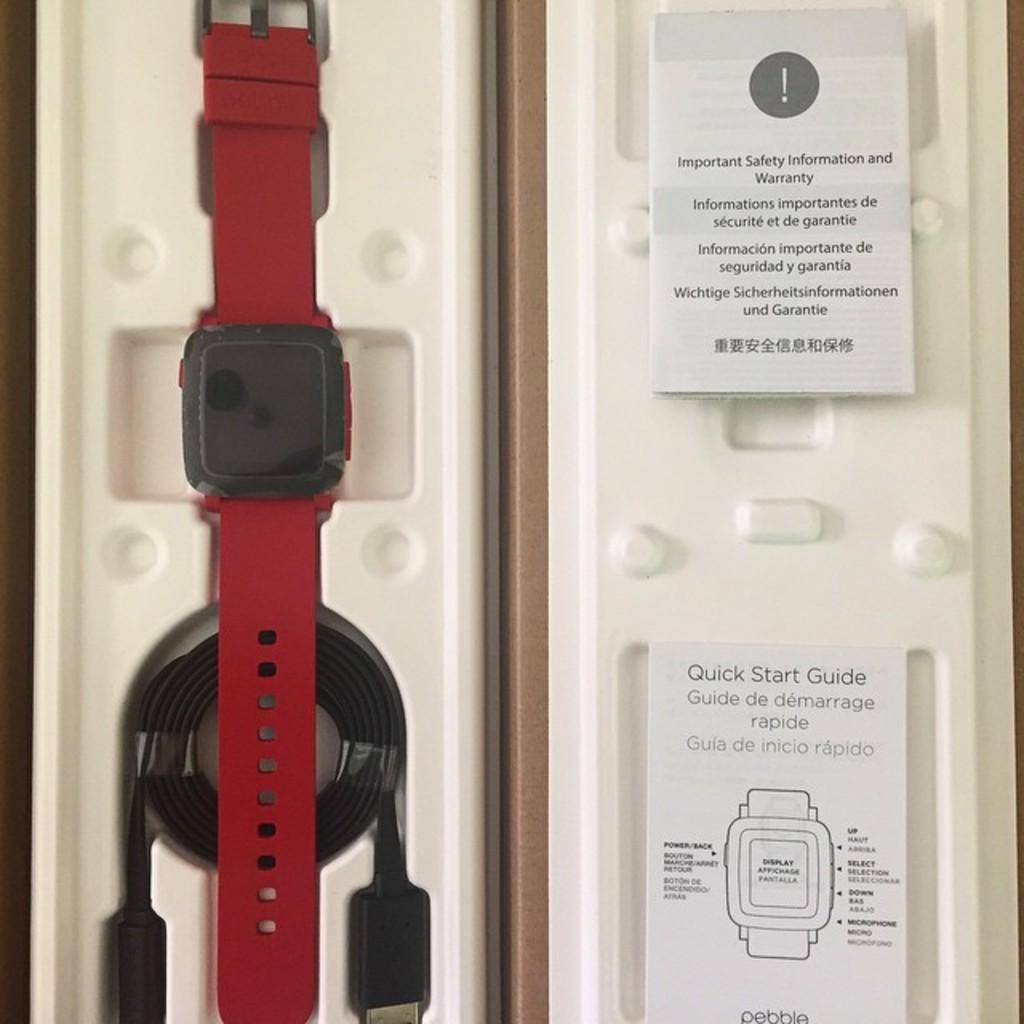What is the title of the bottom manual?
Provide a short and direct response. Quick start guide. What is the brand name at the bottom of the image?
Offer a terse response. Pebble. 